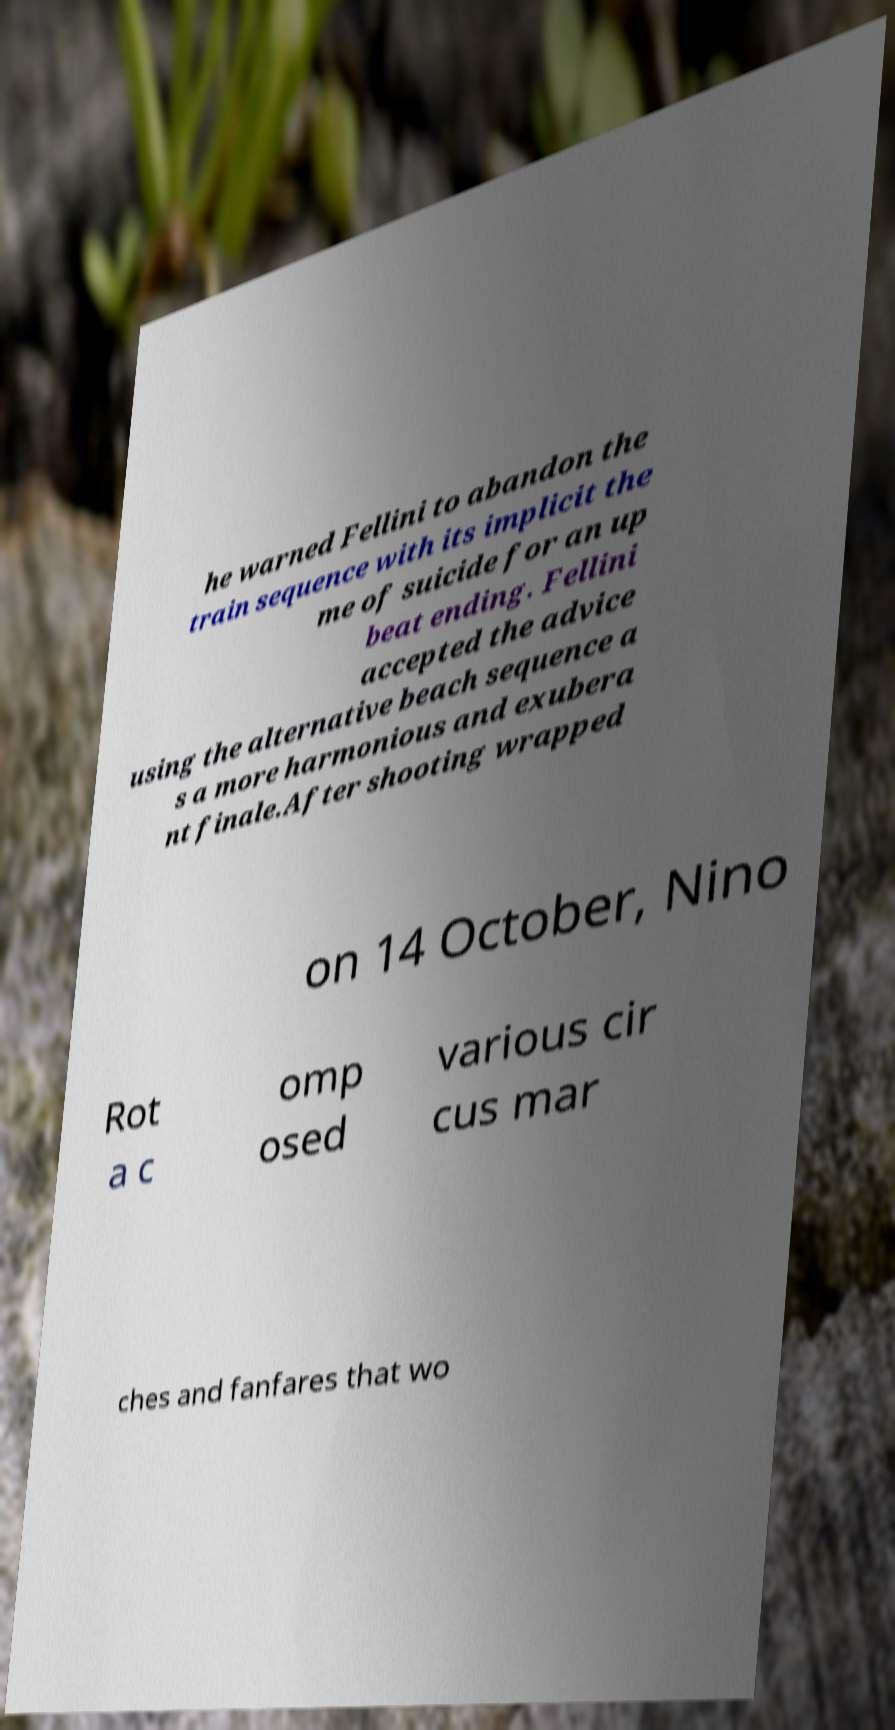Can you accurately transcribe the text from the provided image for me? he warned Fellini to abandon the train sequence with its implicit the me of suicide for an up beat ending. Fellini accepted the advice using the alternative beach sequence a s a more harmonious and exubera nt finale.After shooting wrapped on 14 October, Nino Rot a c omp osed various cir cus mar ches and fanfares that wo 